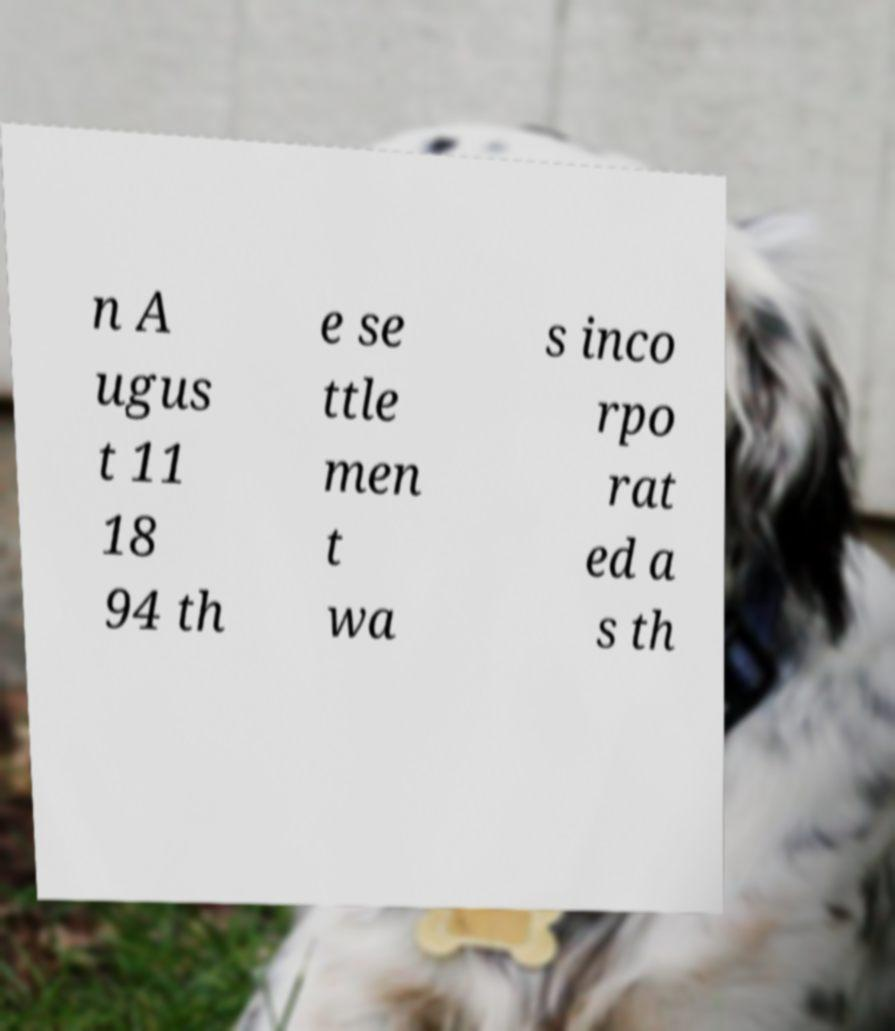Can you read and provide the text displayed in the image?This photo seems to have some interesting text. Can you extract and type it out for me? n A ugus t 11 18 94 th e se ttle men t wa s inco rpo rat ed a s th 